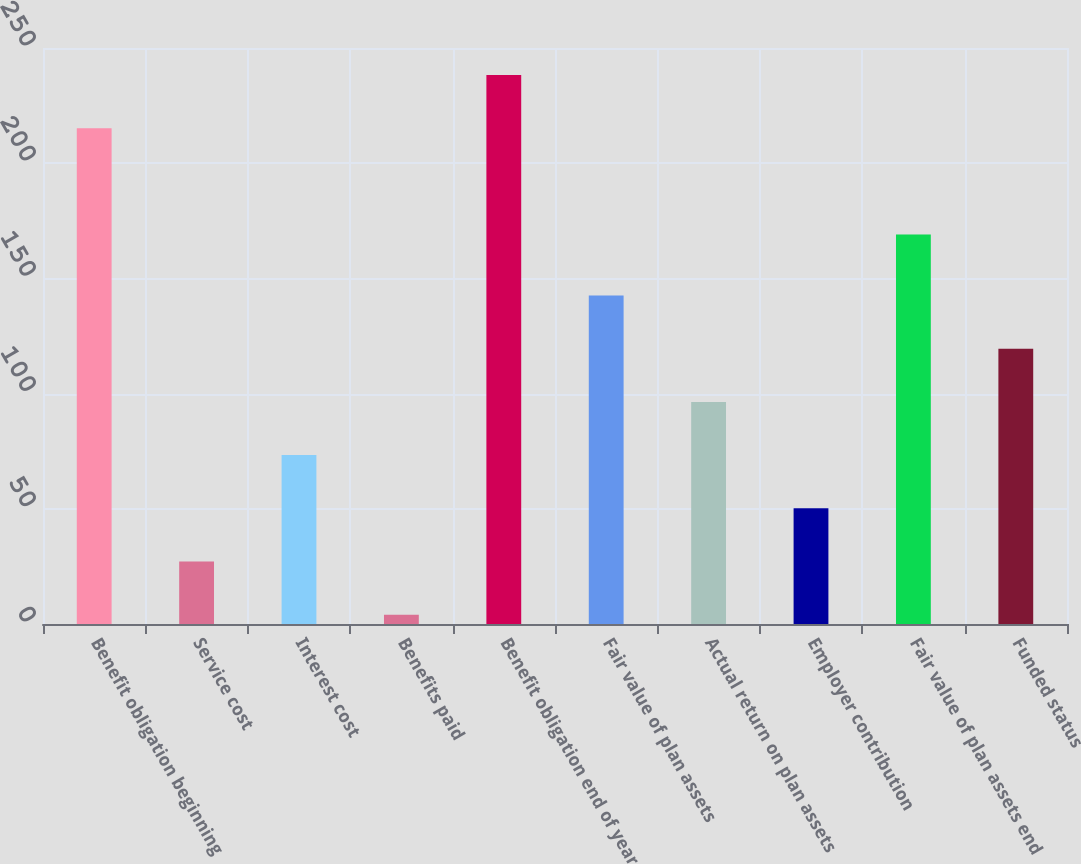Convert chart to OTSL. <chart><loc_0><loc_0><loc_500><loc_500><bar_chart><fcel>Benefit obligation beginning<fcel>Service cost<fcel>Interest cost<fcel>Benefits paid<fcel>Benefit obligation end of year<fcel>Fair value of plan assets<fcel>Actual return on plan assets<fcel>Employer contribution<fcel>Fair value of plan assets end<fcel>Funded status<nl><fcel>215.2<fcel>27.1<fcel>73.3<fcel>4<fcel>238.3<fcel>142.6<fcel>96.4<fcel>50.2<fcel>169<fcel>119.5<nl></chart> 